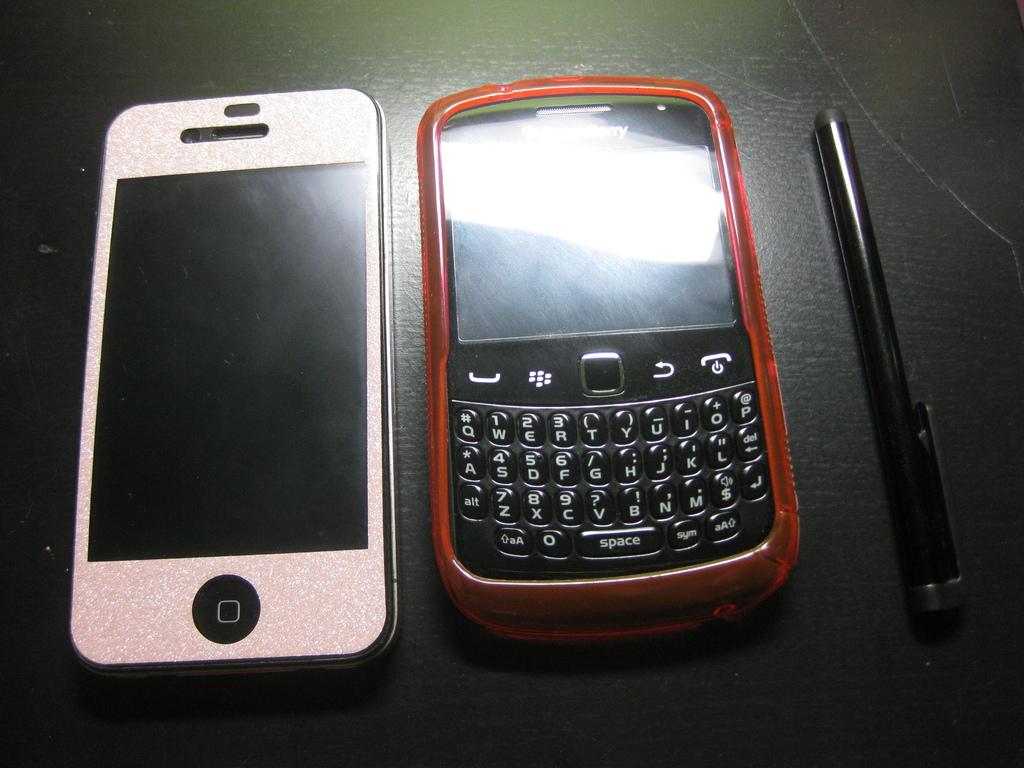What brand of phone is the right one?
Your answer should be very brief. Blackberry. 